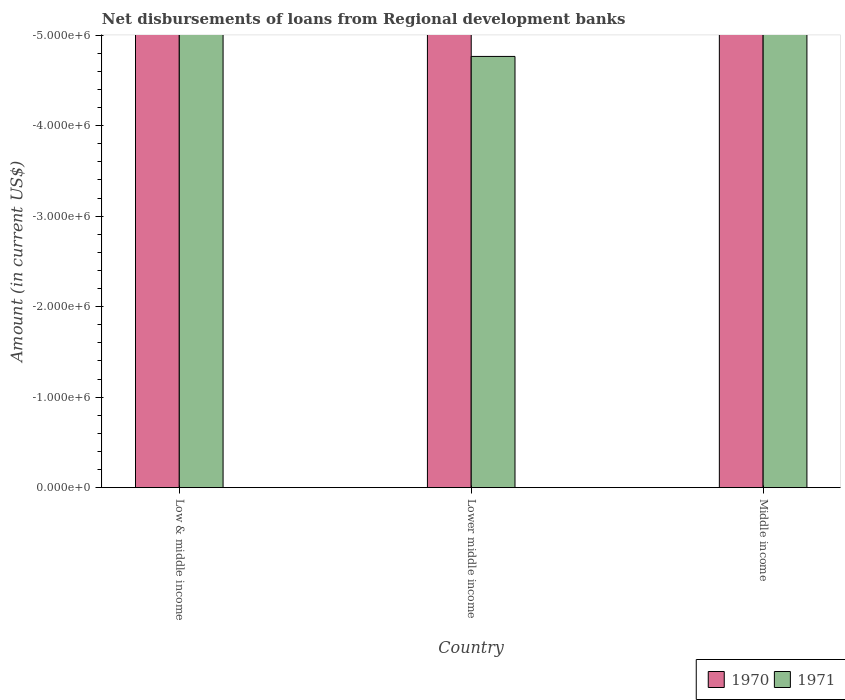How many different coloured bars are there?
Make the answer very short. 0. Are the number of bars on each tick of the X-axis equal?
Keep it short and to the point. Yes. How many bars are there on the 2nd tick from the left?
Make the answer very short. 0. What is the label of the 2nd group of bars from the left?
Offer a terse response. Lower middle income. In how many cases, is the number of bars for a given country not equal to the number of legend labels?
Your response must be concise. 3. Across all countries, what is the minimum amount of disbursements of loans from regional development banks in 1970?
Provide a succinct answer. 0. What is the total amount of disbursements of loans from regional development banks in 1970 in the graph?
Provide a succinct answer. 0. What is the average amount of disbursements of loans from regional development banks in 1970 per country?
Ensure brevity in your answer.  0. In how many countries, is the amount of disbursements of loans from regional development banks in 1970 greater than -1200000 US$?
Your response must be concise. 0. How many bars are there?
Offer a very short reply. 0. How many countries are there in the graph?
Your answer should be very brief. 3. What is the difference between two consecutive major ticks on the Y-axis?
Offer a very short reply. 1.00e+06. Are the values on the major ticks of Y-axis written in scientific E-notation?
Provide a short and direct response. Yes. Does the graph contain any zero values?
Offer a very short reply. Yes. How are the legend labels stacked?
Ensure brevity in your answer.  Horizontal. What is the title of the graph?
Provide a short and direct response. Net disbursements of loans from Regional development banks. Does "2012" appear as one of the legend labels in the graph?
Your answer should be very brief. No. What is the label or title of the Y-axis?
Provide a succinct answer. Amount (in current US$). What is the Amount (in current US$) of 1970 in Low & middle income?
Offer a very short reply. 0. What is the Amount (in current US$) in 1970 in Lower middle income?
Offer a very short reply. 0. What is the Amount (in current US$) of 1971 in Lower middle income?
Make the answer very short. 0. What is the Amount (in current US$) in 1971 in Middle income?
Your response must be concise. 0. What is the total Amount (in current US$) of 1970 in the graph?
Give a very brief answer. 0. What is the total Amount (in current US$) of 1971 in the graph?
Your answer should be compact. 0. What is the average Amount (in current US$) of 1970 per country?
Make the answer very short. 0. What is the average Amount (in current US$) of 1971 per country?
Give a very brief answer. 0. 